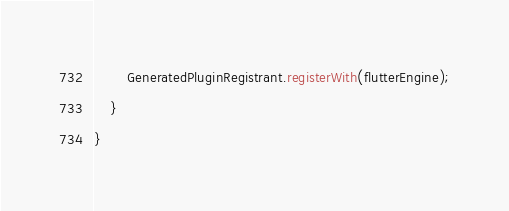<code> <loc_0><loc_0><loc_500><loc_500><_Kotlin_>        GeneratedPluginRegistrant.registerWith(flutterEngine);
    }
}
</code> 